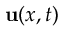Convert formula to latex. <formula><loc_0><loc_0><loc_500><loc_500>\mathbf u ( x , t )</formula> 